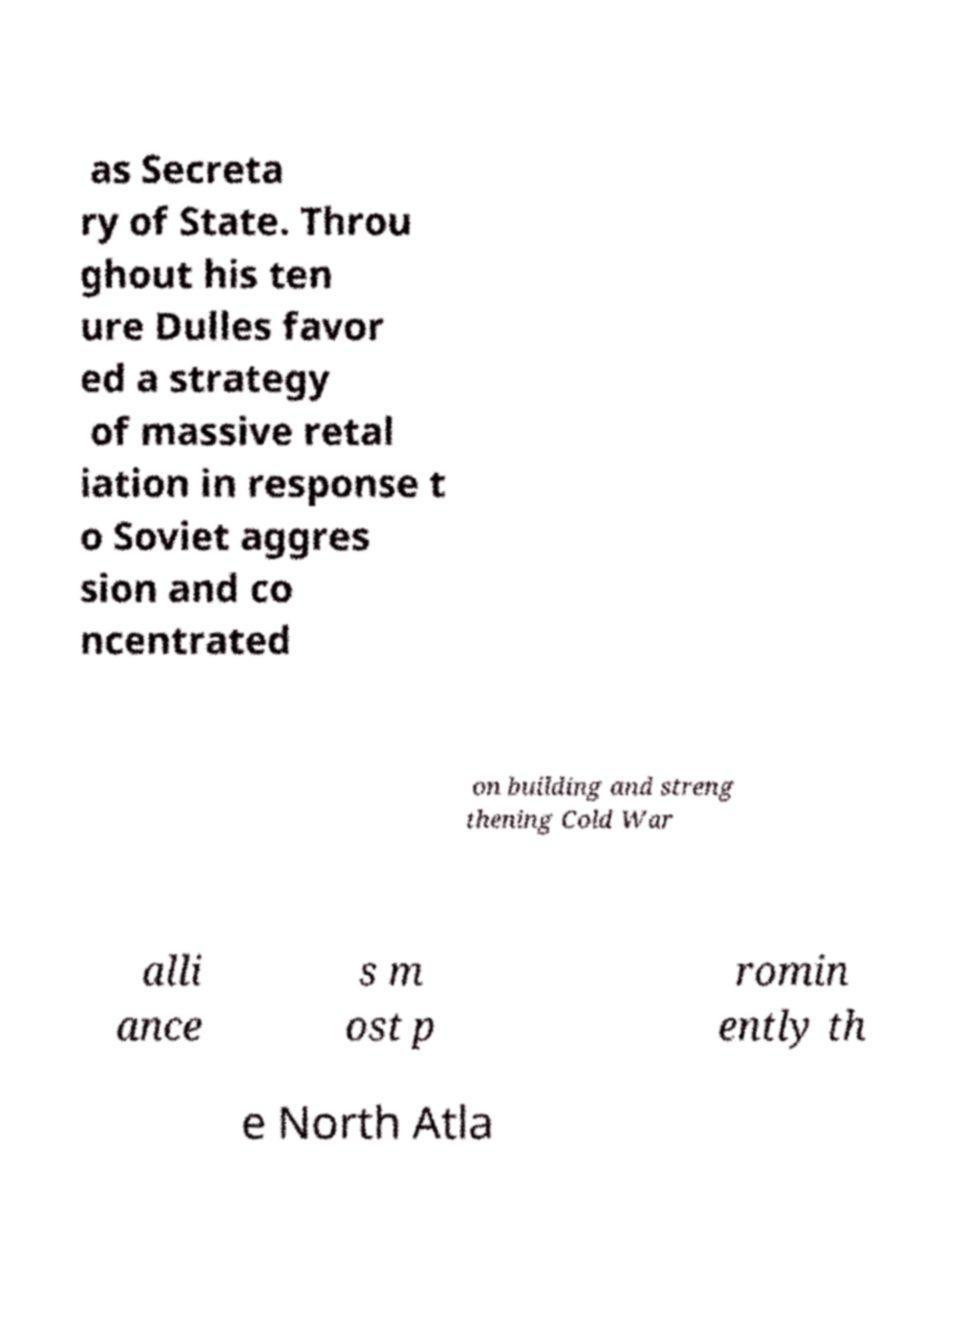Please read and relay the text visible in this image. What does it say? as Secreta ry of State. Throu ghout his ten ure Dulles favor ed a strategy of massive retal iation in response t o Soviet aggres sion and co ncentrated on building and streng thening Cold War alli ance s m ost p romin ently th e North Atla 